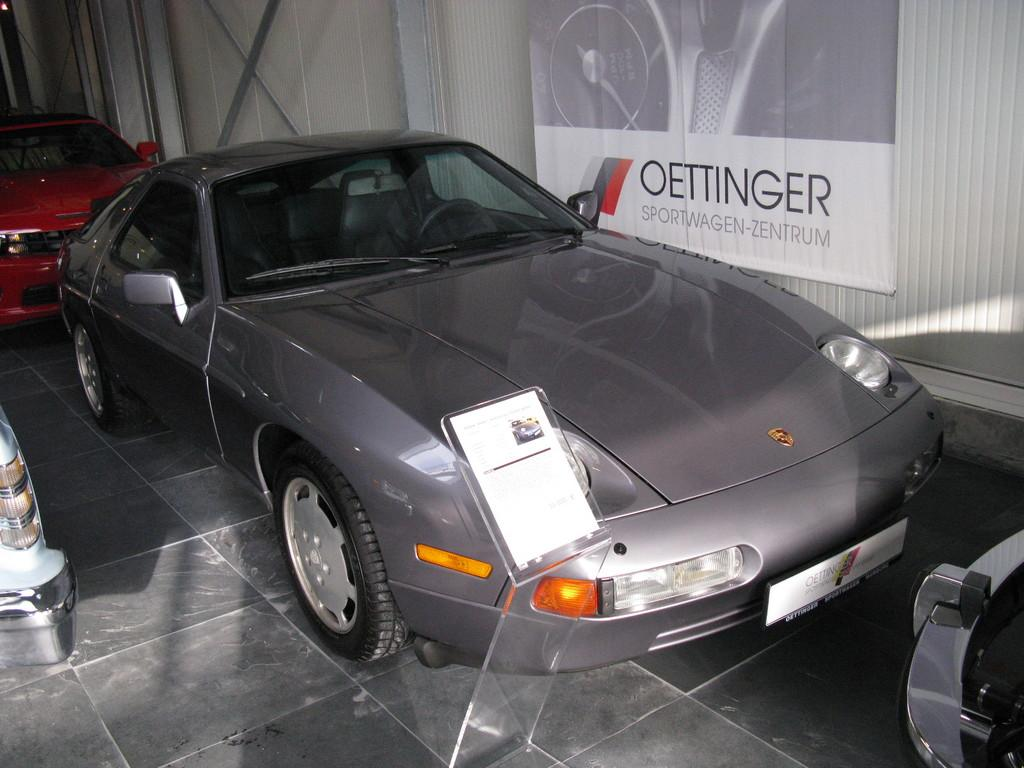What type of objects are on the floor in the image? There are colorful cars on the floor in the image. What type of architectural feature is visible in the image? There is a glass door visible in the image. What is attached to the glass door? A white color banner is attached to the glass door. What type of appliance is on fire in the image? There is no appliance on fire in the image; the provided facts do not mention any fire or appliance. 